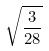Convert formula to latex. <formula><loc_0><loc_0><loc_500><loc_500>\sqrt { \frac { 3 } { 2 8 } }</formula> 